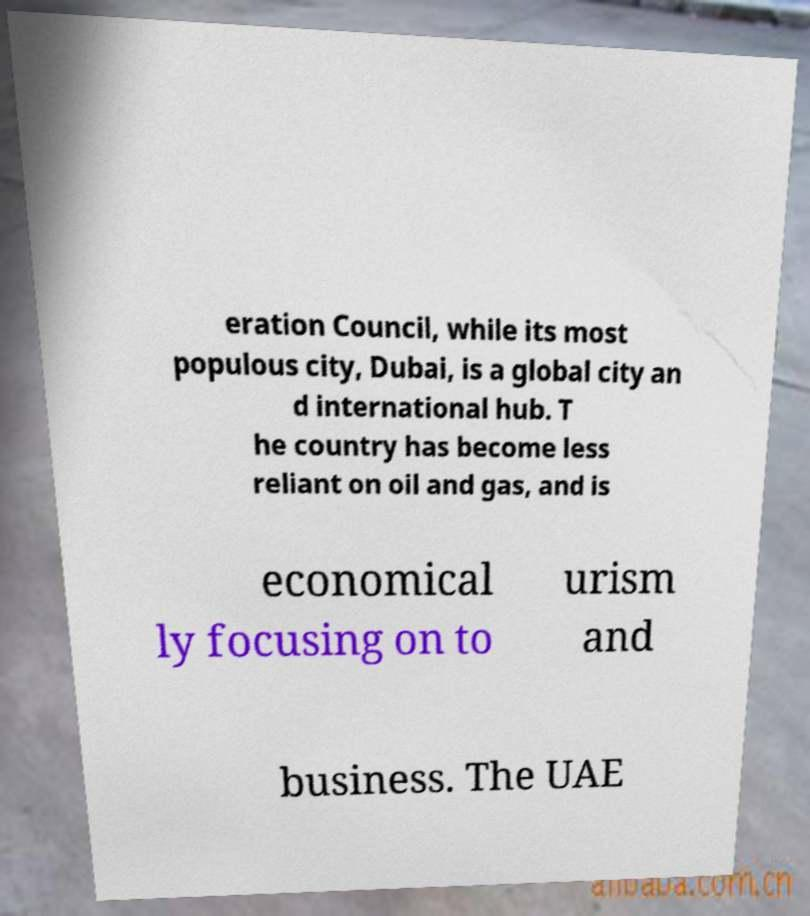Please identify and transcribe the text found in this image. eration Council, while its most populous city, Dubai, is a global city an d international hub. T he country has become less reliant on oil and gas, and is economical ly focusing on to urism and business. The UAE 